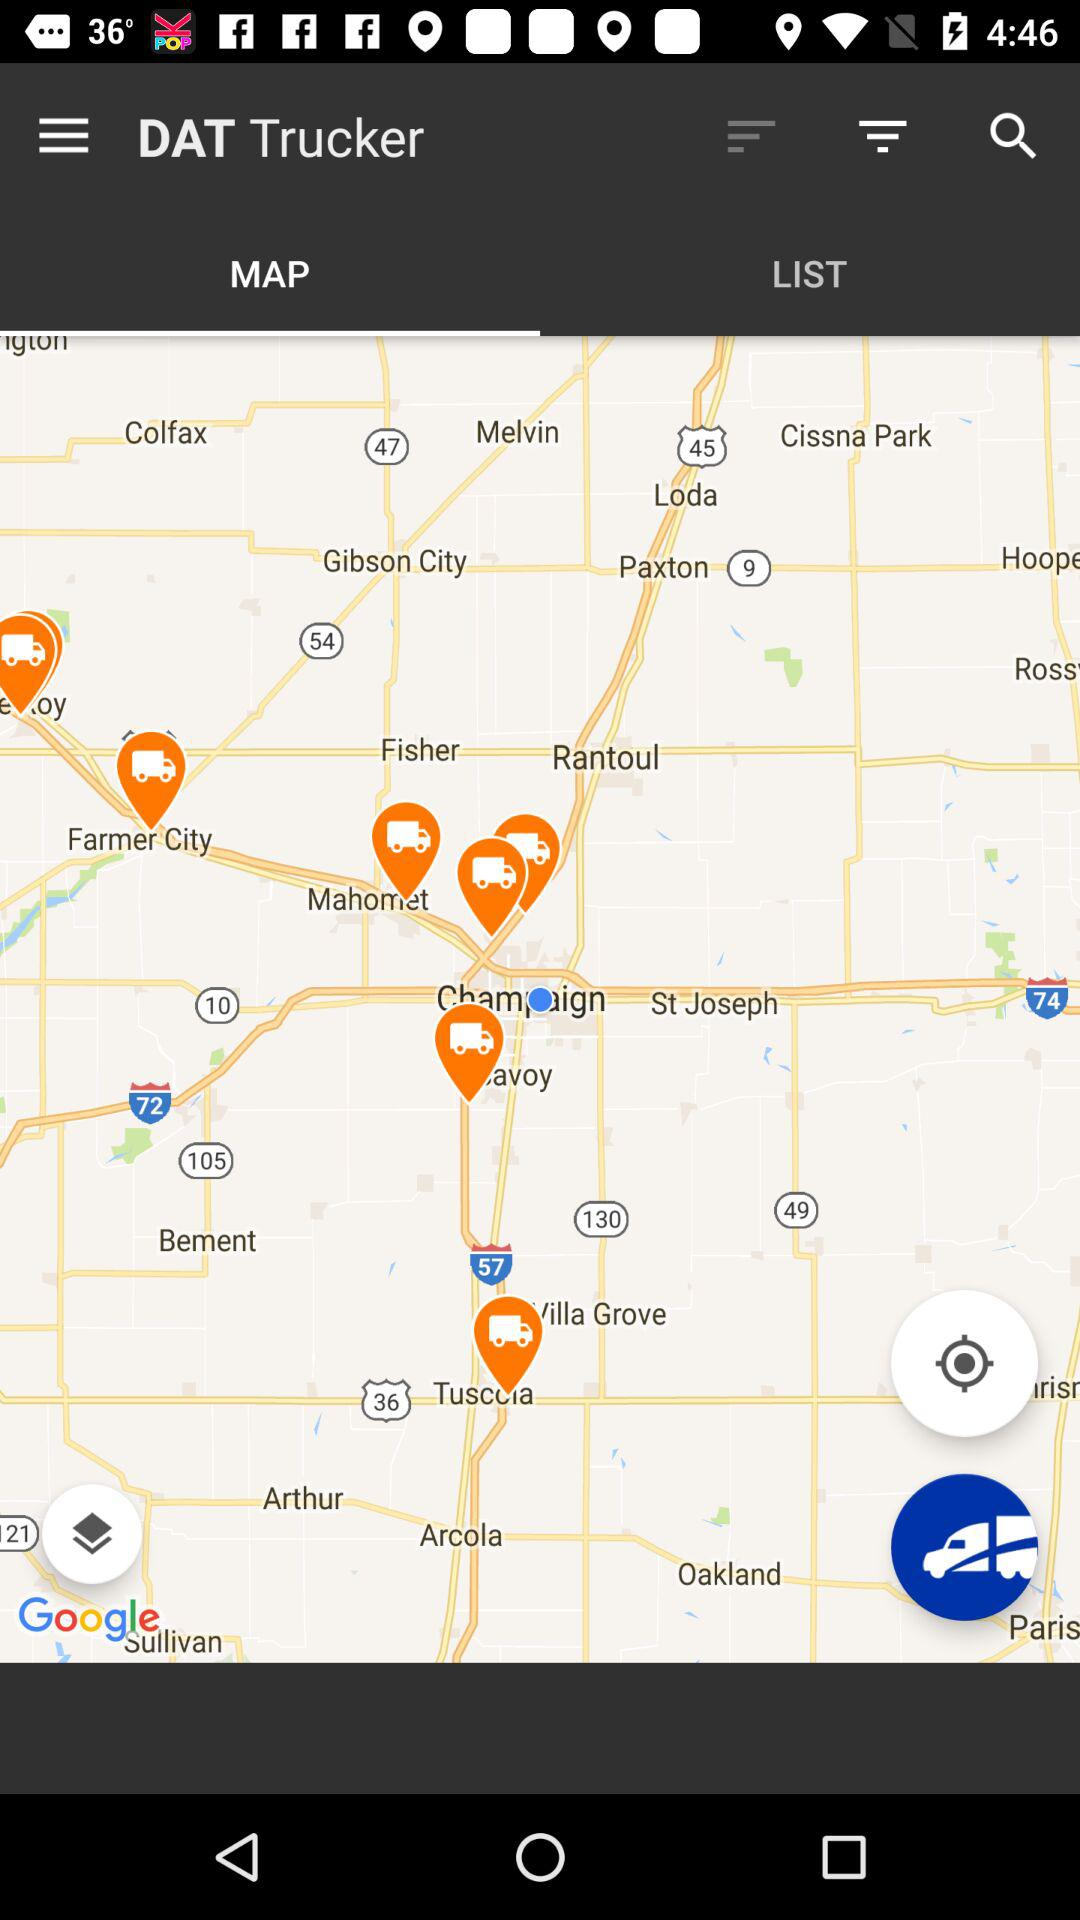Which tab am I using? You are using the tab "MAP". 